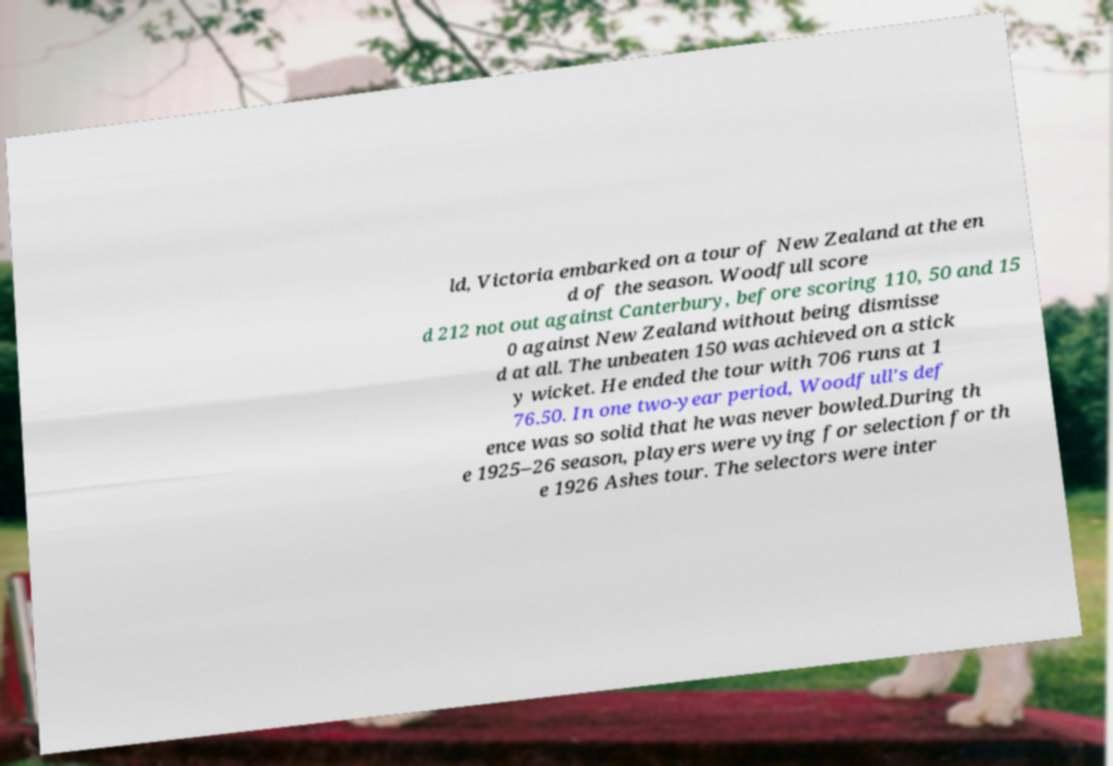For documentation purposes, I need the text within this image transcribed. Could you provide that? ld, Victoria embarked on a tour of New Zealand at the en d of the season. Woodfull score d 212 not out against Canterbury, before scoring 110, 50 and 15 0 against New Zealand without being dismisse d at all. The unbeaten 150 was achieved on a stick y wicket. He ended the tour with 706 runs at 1 76.50. In one two-year period, Woodfull's def ence was so solid that he was never bowled.During th e 1925–26 season, players were vying for selection for th e 1926 Ashes tour. The selectors were inter 